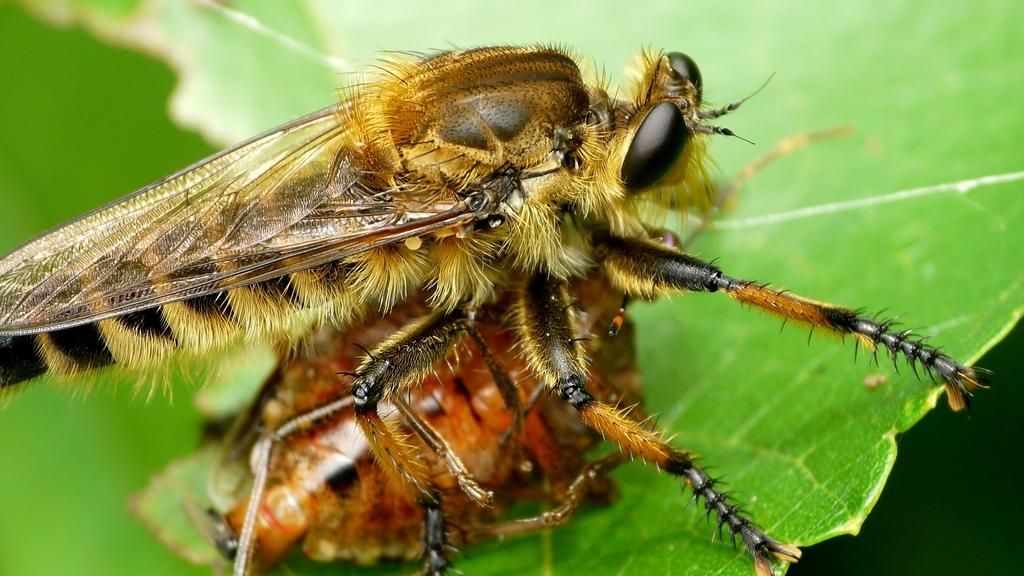What is present on the leaf in the image? There is an insect on a leaf in the image. Can you describe the background of the image? The background of the image is blurry. What type of rose is being requested by the insect in the image? There is no rose present in the image, and the insect is not making any requests. 